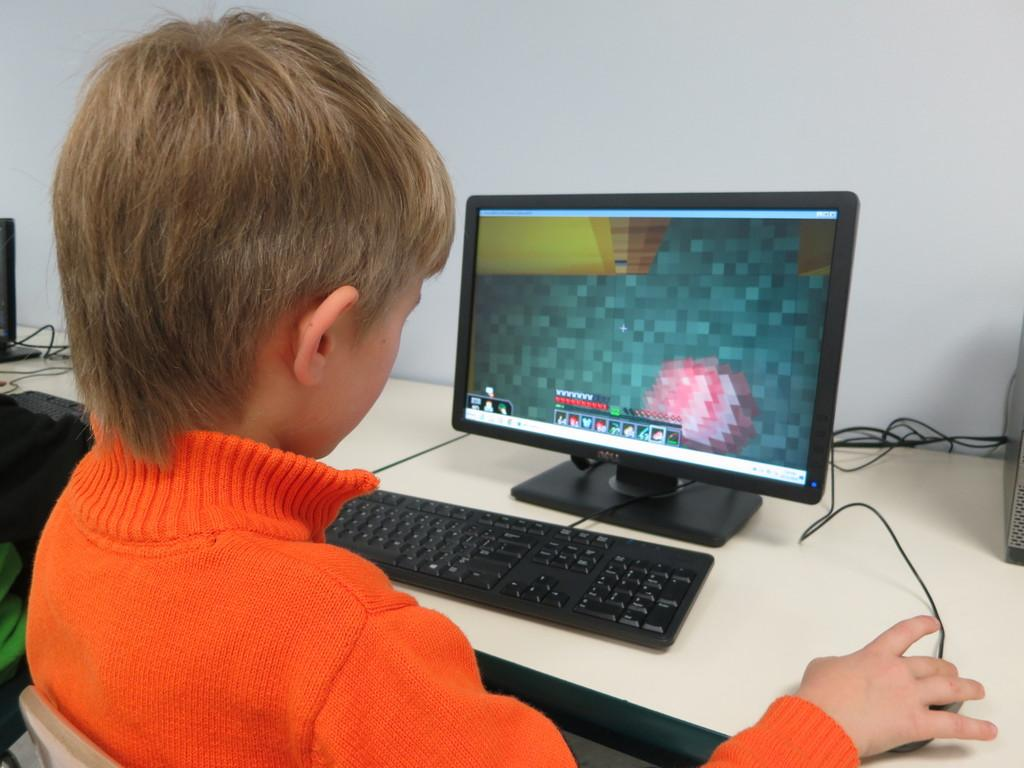<image>
Share a concise interpretation of the image provided. A boy is playing Minecraft on a Dell brand computer. 